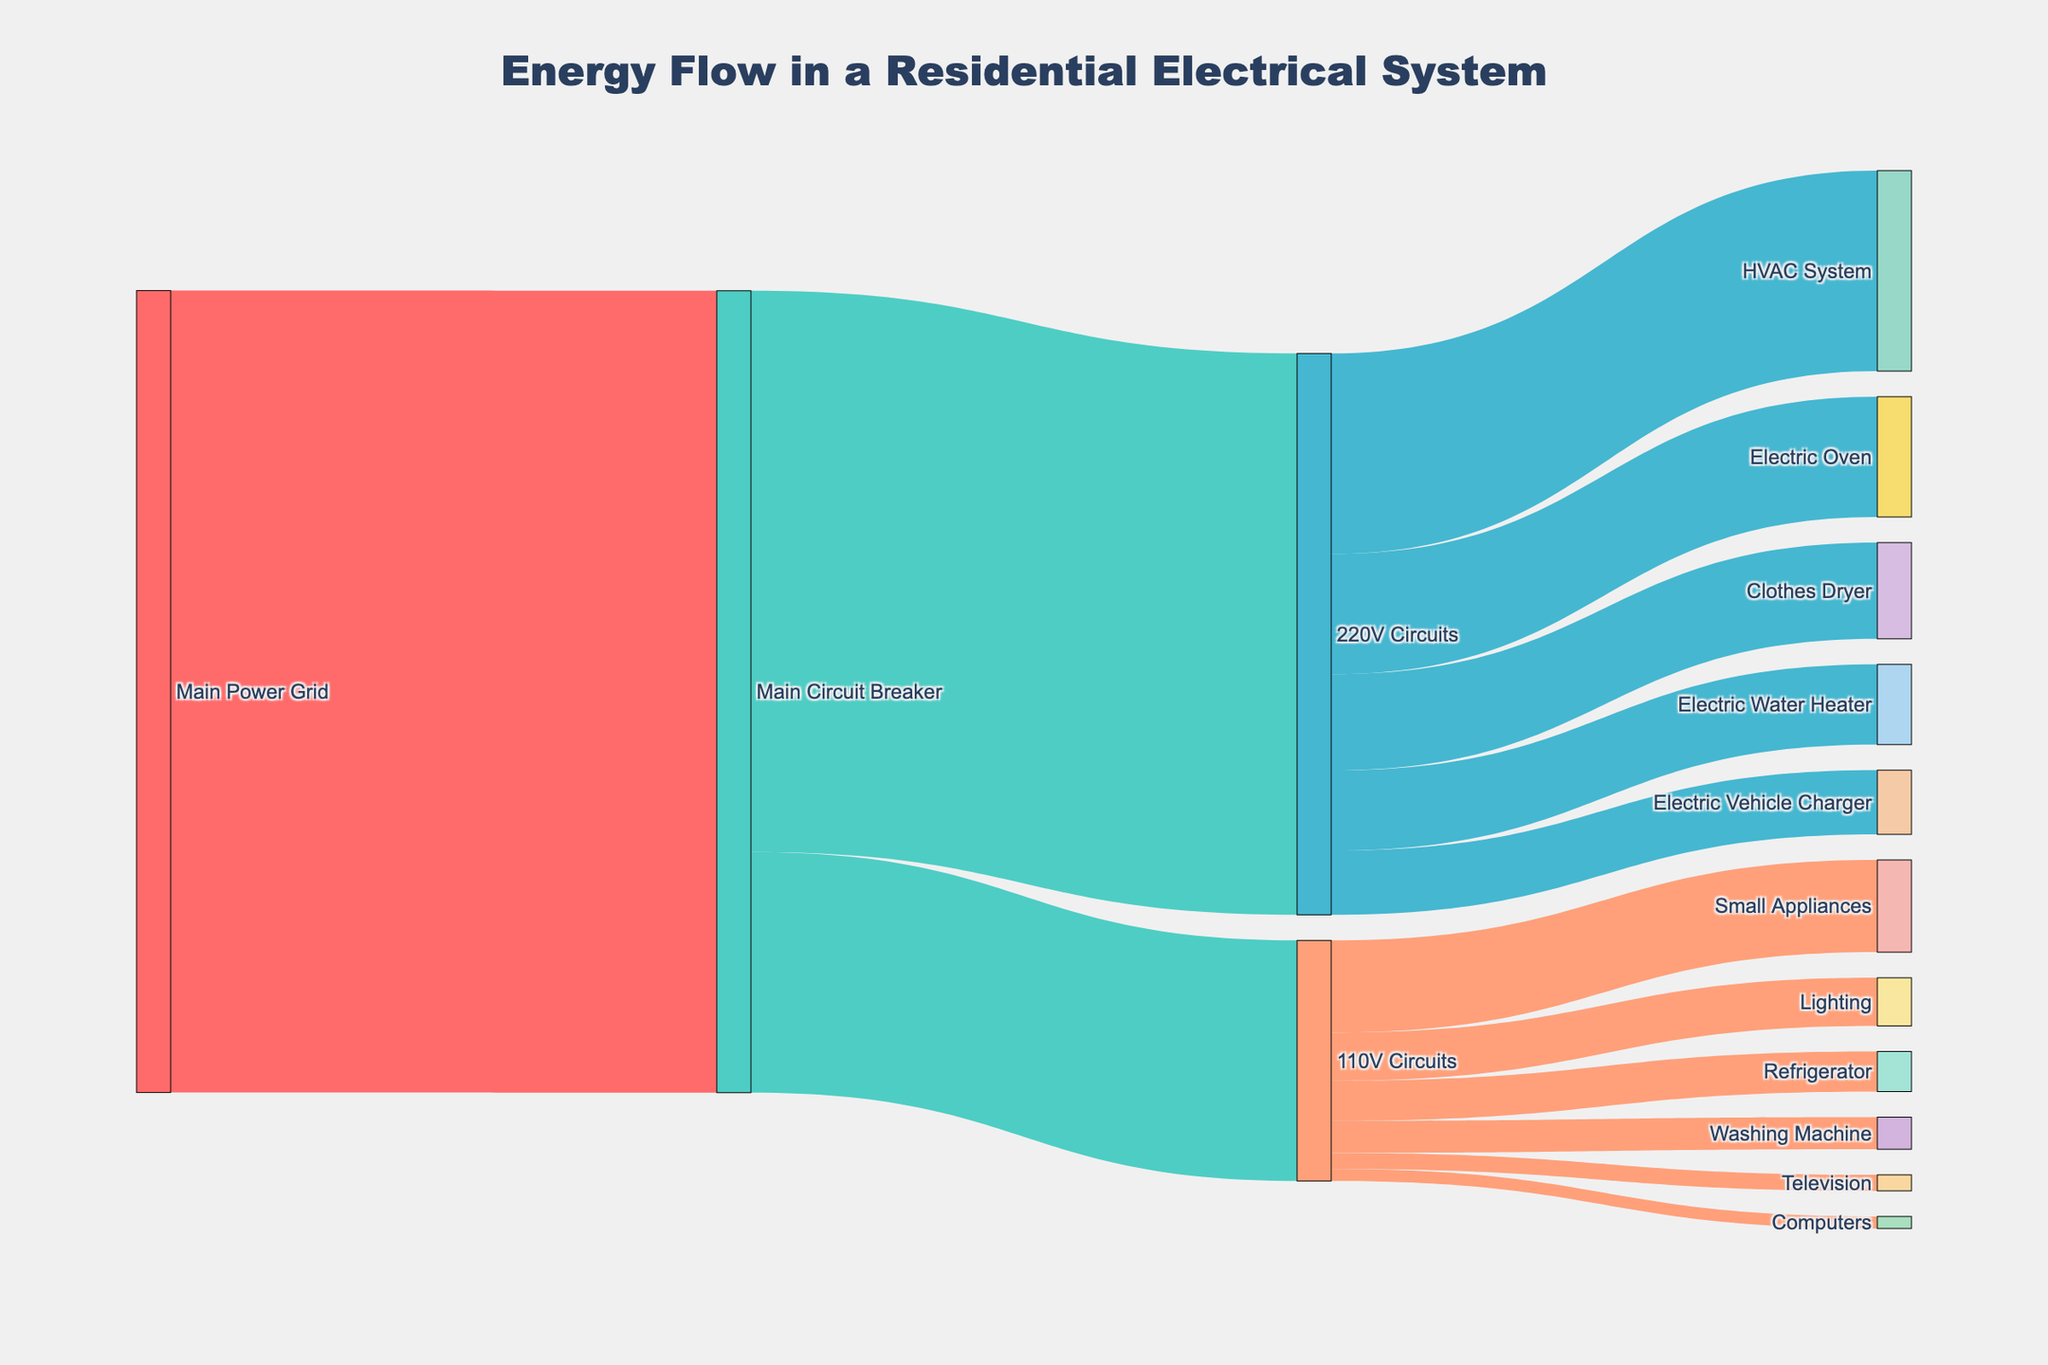What is the total energy supplied to the household? The title of the diagram indicates "Energy Flow in a Residential Electrical System." The flow starts from the "Main Power Grid" with a value of 10,000 units supplied to the "Main Circuit Breaker."
Answer: 10,000 units How much energy is allocated to 220V circuits? Looking at the flow from the "Main Circuit Breaker" to "220V Circuits" in the diagram, the energy value is 7000 units.
Answer: 7000 units How much energy is assigned to the Electric Oven? Follow the energy flow from "220V Circuits" to "Electric Oven," which shows a value of 1500 units.
Answer: 1500 units What's the total energy usage of the 110V circuits? Sum the values from "110V Circuits" to its targets: Lighting (600) + Refrigerator (500) + Washing Machine (400) + Television (200) + Computers (150) + Small Appliances (1150). The total is 600 + 500 + 400 + 200 + 150 + 1150 = 3000 units.
Answer: 3000 units Which appliance in the 220V circuits uses the most energy? Compare the values of energy flow targets from "220V Circuits": HVAC System (2500), Electric Oven (1500), Clothes Dryer (1200), Electric Water Heater (1000), Electric Vehicle Charger (800). The HVAC System has the highest value at 2500 units.
Answer: HVAC System How does the energy usage of Small Appliances compare with the Refrigerator? Small Appliances consume 1150 units, and the Refrigerator consumes 500 units. Comparing these, 1150 is greater than 500 units.
Answer: Small Appliances use more What is the combined energy consumption of the HVAC System and Electric Vehicle Charger? Sum the energy values: HVAC System (2500) + Electric Vehicle Charger (800) = 2500 + 800 = 3300 units.
Answer: 3300 units How much more energy is used by the Electric Oven compared to the Washing Machine? The Electric Oven uses 1500 units, while the Washing Machine uses 400 units. The difference is 1500 - 400 = 1100 units.
Answer: 1100 units What percentage of the total energy from the Main Circuit Breaker goes to 110V Circuits? The total energy from the Main Circuit Breaker is 10,000 units, and 110V Circuits get 3000 units. The percentage is (3000 / 10000) * 100 = 30%.
Answer: 30% Which circuit type, 220V or 110V, has a higher total energy allocation, and by how much? 220V Circuits get 7000 units, and 110V Circuits get 3000 units. The difference is 7000 - 3000 = 4000 units. 220V Circuits have a higher allocation.
Answer: 220V Circuits by 4000 units 